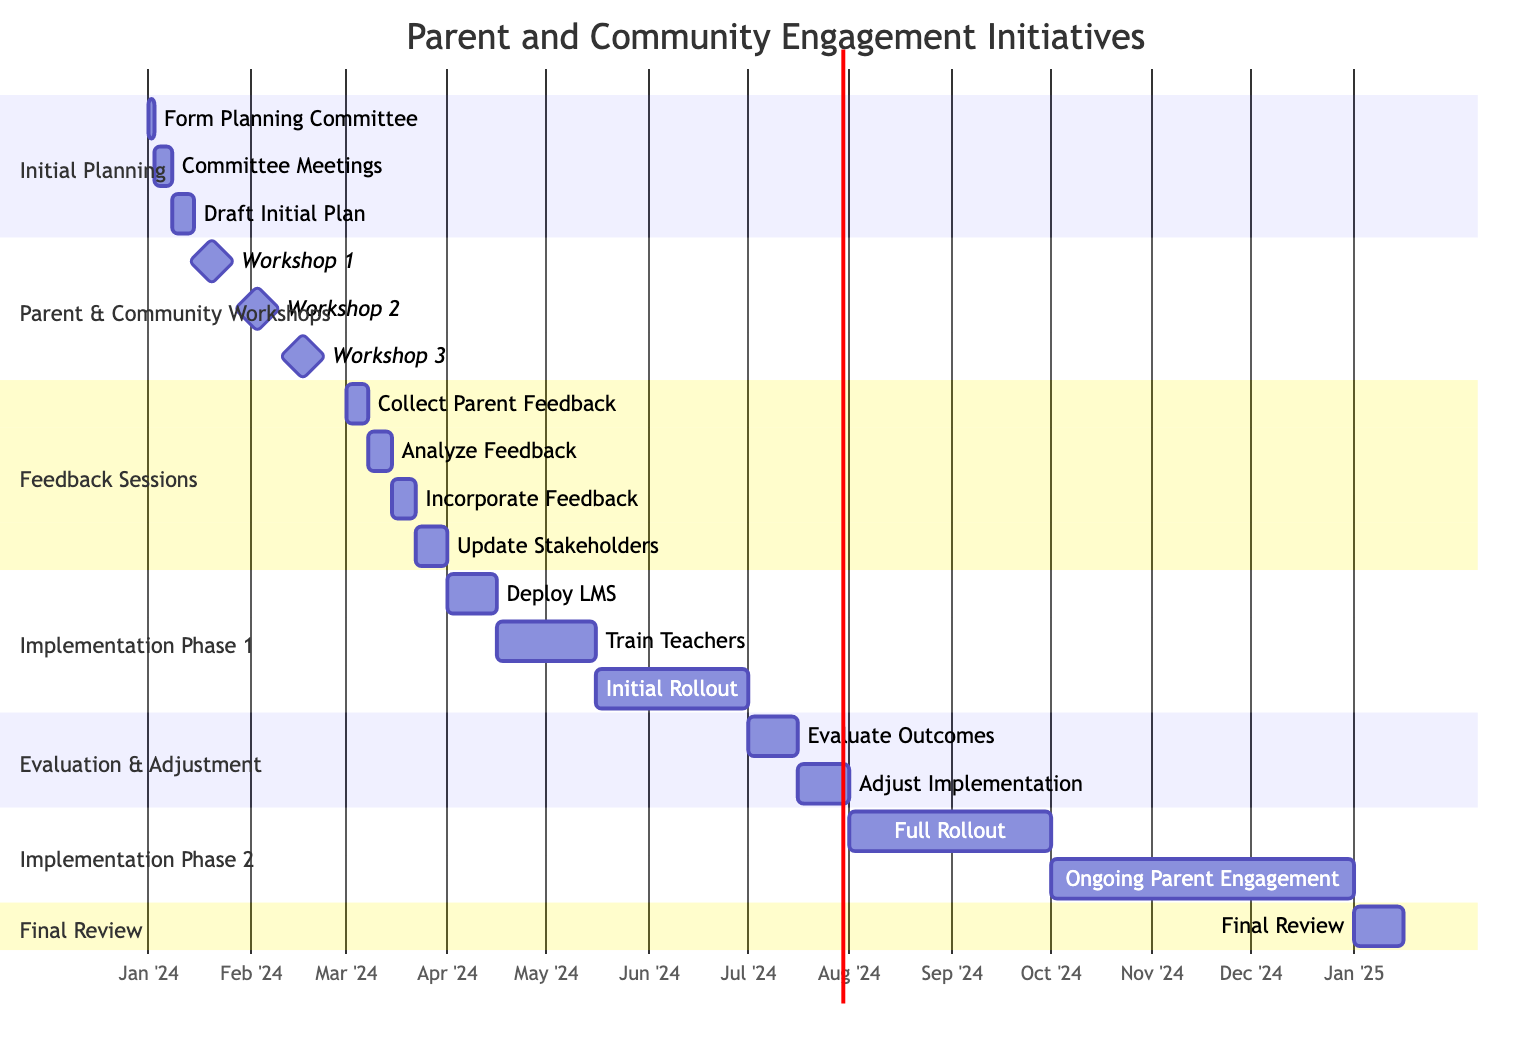What is the duration of the "Initial Planning" phase? The "Initial Planning" phase starts on January 1, 2024, and ends on January 14, 2024. To find the duration, we can subtract the start date from the end date. There are 14 days from January 1 to January 14 inclusive.
Answer: 14 days How many workshops are scheduled during the "Parent and Community Workshops" section? The "Parent and Community Workshops" section lists three workshops: Workshop 1, Workshop 2, and Workshop 3. By counting each of these listed workshops, we determine there are three workshops scheduled.
Answer: 3 workshops What task occurs right after "Analyze Feedback"? According to the sequence of tasks in the "Feedback Sessions" section, "Incorporate Feedback into Plan" occurs immediately after "Analyze Feedback". We can trace the order of tasks in sections to identify the immediate successor.
Answer: Incorporate Feedback into Plan When does the "Full Rollout Across School" phase start? Looking at the timeline for the "Implementation Phase 2," "Full Rollout Across School" starts on August 1, 2024. This date is indicated directly in the diagram, specifying the beginning of this phase.
Answer: August 1, 2024 What is the total length of the "Evaluation and Adjustment" section? The "Evaluation and Adjustment" section spans from July 1, 2024, to July 31, 2024. To calculate the length, we note the start date and the end date and find it covers 31 days in total, as July has 31 days and we include both start and end in our count.
Answer: 31 days Which task has the longest duration in "Implementation Phase 1"? Within "Implementation Phase 1," the tasks include "Deploy Learning Management System," "Train Teachers on New System," and "Initial Rollout to Selected Classes." Looking at each task's duration, "Initial Rollout to Selected Classes" has a duration of 46 days, which is longer than the others. By comparing the durations, we identify it as the longest.
Answer: Initial Rollout to Selected Classes What is the last task scheduled before the "Final Review"? The "Final Review" spans from January 1, 2025, to January 15, 2025, marking it as the last segment of the timeline. The preceding phase is "Implementation Phase 2," which includes "Ongoing Parent Engagement" scheduled until December 31, 2024. Therefore, the last task prior to the "Final Review" is "Ongoing Parent Engagement."
Answer: Ongoing Parent Engagement How many days are allocated for "Training Teachers on New System"? The "Training Teachers on New System" task is scheduled from April 16, 2024, to May 15, 2024. To determine the allocated days, we can count the number of days between these two dates, which totals 30 days for the training period.
Answer: 30 days 